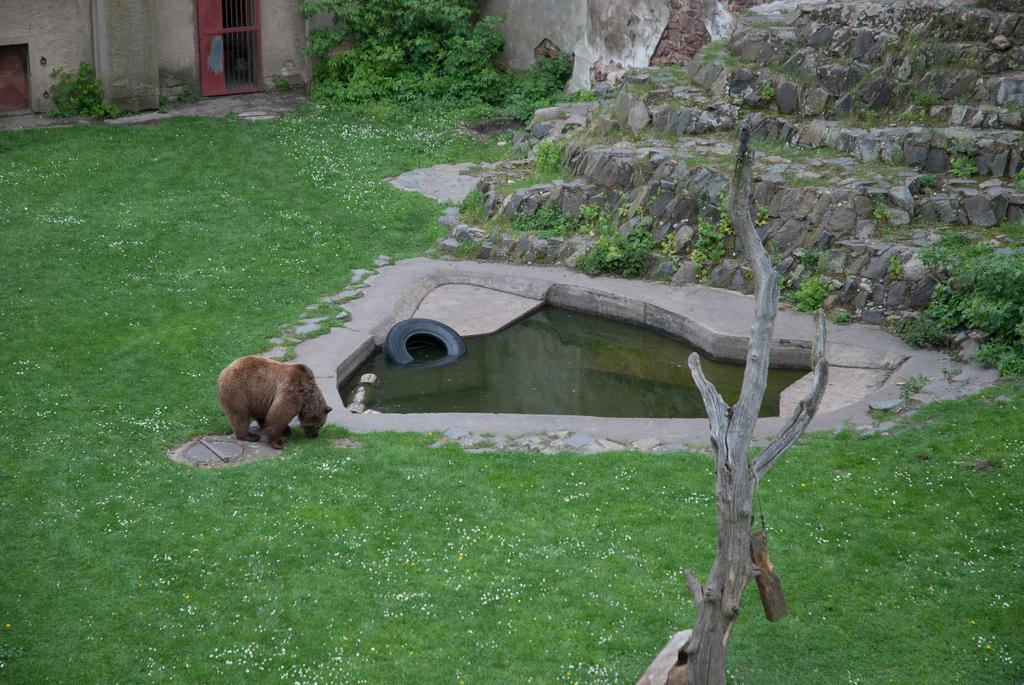What animal can be seen in the image? There is a bear in the image. What object is in the water in the image? There is a tire in the water in the image. What type of vegetation is visible in the background of the image? There are trees and grass in the background of the image. What type of terrain is visible in the background of the image? There are rocks in the background of the image. How does the zephyr affect the bear's balance in the image? There is no mention of a zephyr or any wind in the image, so it cannot affect the bear's balance. 